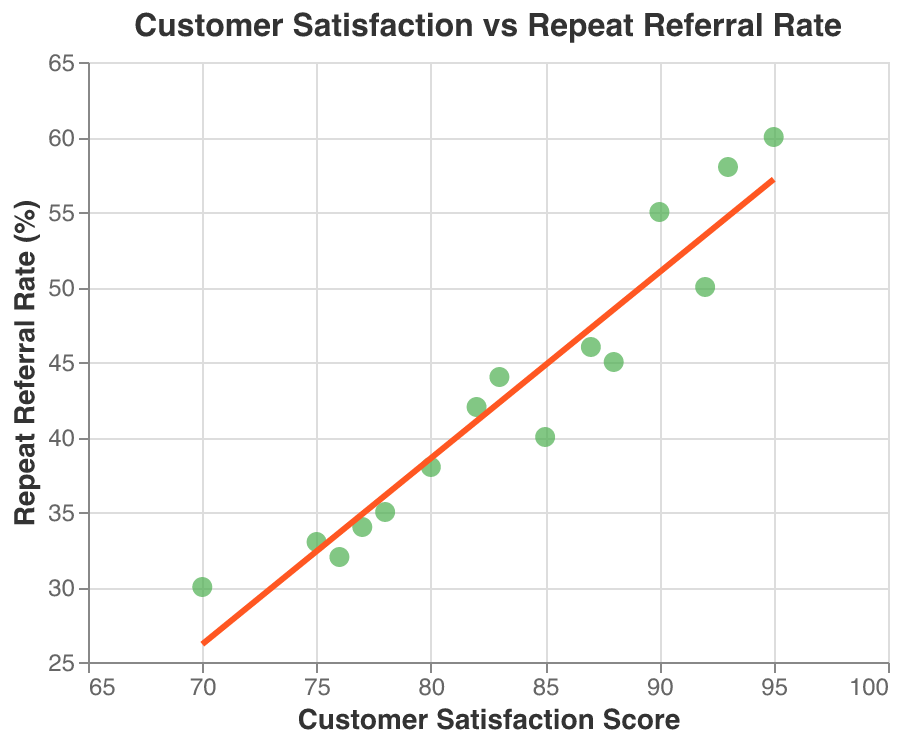What does the title of the scatter plot say? The title of the scatter plot is displayed at the top of the figure and it describes what the figure is about.
Answer: Customer Satisfaction vs Repeat Referral Rate How many data points are there in the scatter plot? The scatter plot has a point for each customer's satisfaction score and their repeat referral rate. Count these points on the plot.
Answer: 15 What is the range of the x-axis (Customer Satisfaction Score)? The x-axis represents Customer Satisfaction Score. Look at the minimum and maximum values indicated on this axis.
Answer: 65 to 100 What is the color of the trend line in the scatter plot? The trend line in the scatter plot is used to show the general direction of the data trend. Look at the color of this trend line.
Answer: Red (Orange) Who has the highest repeat referral rate and what is that rate? The highest repeat referral rate can be identified as the largest y-axis value, find the corresponding customer name.
Answer: Eva Davis, 60 Which customer has the lowest satisfaction score and what is their repeat referral rate? Find the data point with the lowest x-axis value (Customer Satisfaction Score) and check the associated customer name and repeat referral rate.
Answer: Frank Miller, 30 What is the relationship between Customer Satisfaction Scores and Repeat Referral Rates as depicted by the trend line? Observe the trend line's direction and slope to determine the overall relationship shown between Customer Satisfaction Scores and Repeat Referral Rates.
Answer: Positive correlation What are the average Customer Satisfaction Score and Repeat Referral Rate for all customers? To find the average, sum up all the Customer Satisfaction Scores and divide by the total number of customers, then do the same for the Repeat Referral Rates.
Answer: 83.13; 42.87 Which customer has a repeat referral rate closest to 50%? Find the data point where the Repeat Referral Rate value is closest to 50% and note the associated customer name.
Answer: Carol Williams Compare David Brown and Karen Thomas: who has a higher Customer Satisfaction Score and who has a higher Repeat Referral Rate? Look at the data points for both customers and compare their Customer Satisfaction Scores and Repeat Referral Rates to see who has the higher values.
Answer: Karen Thomas (Both) 